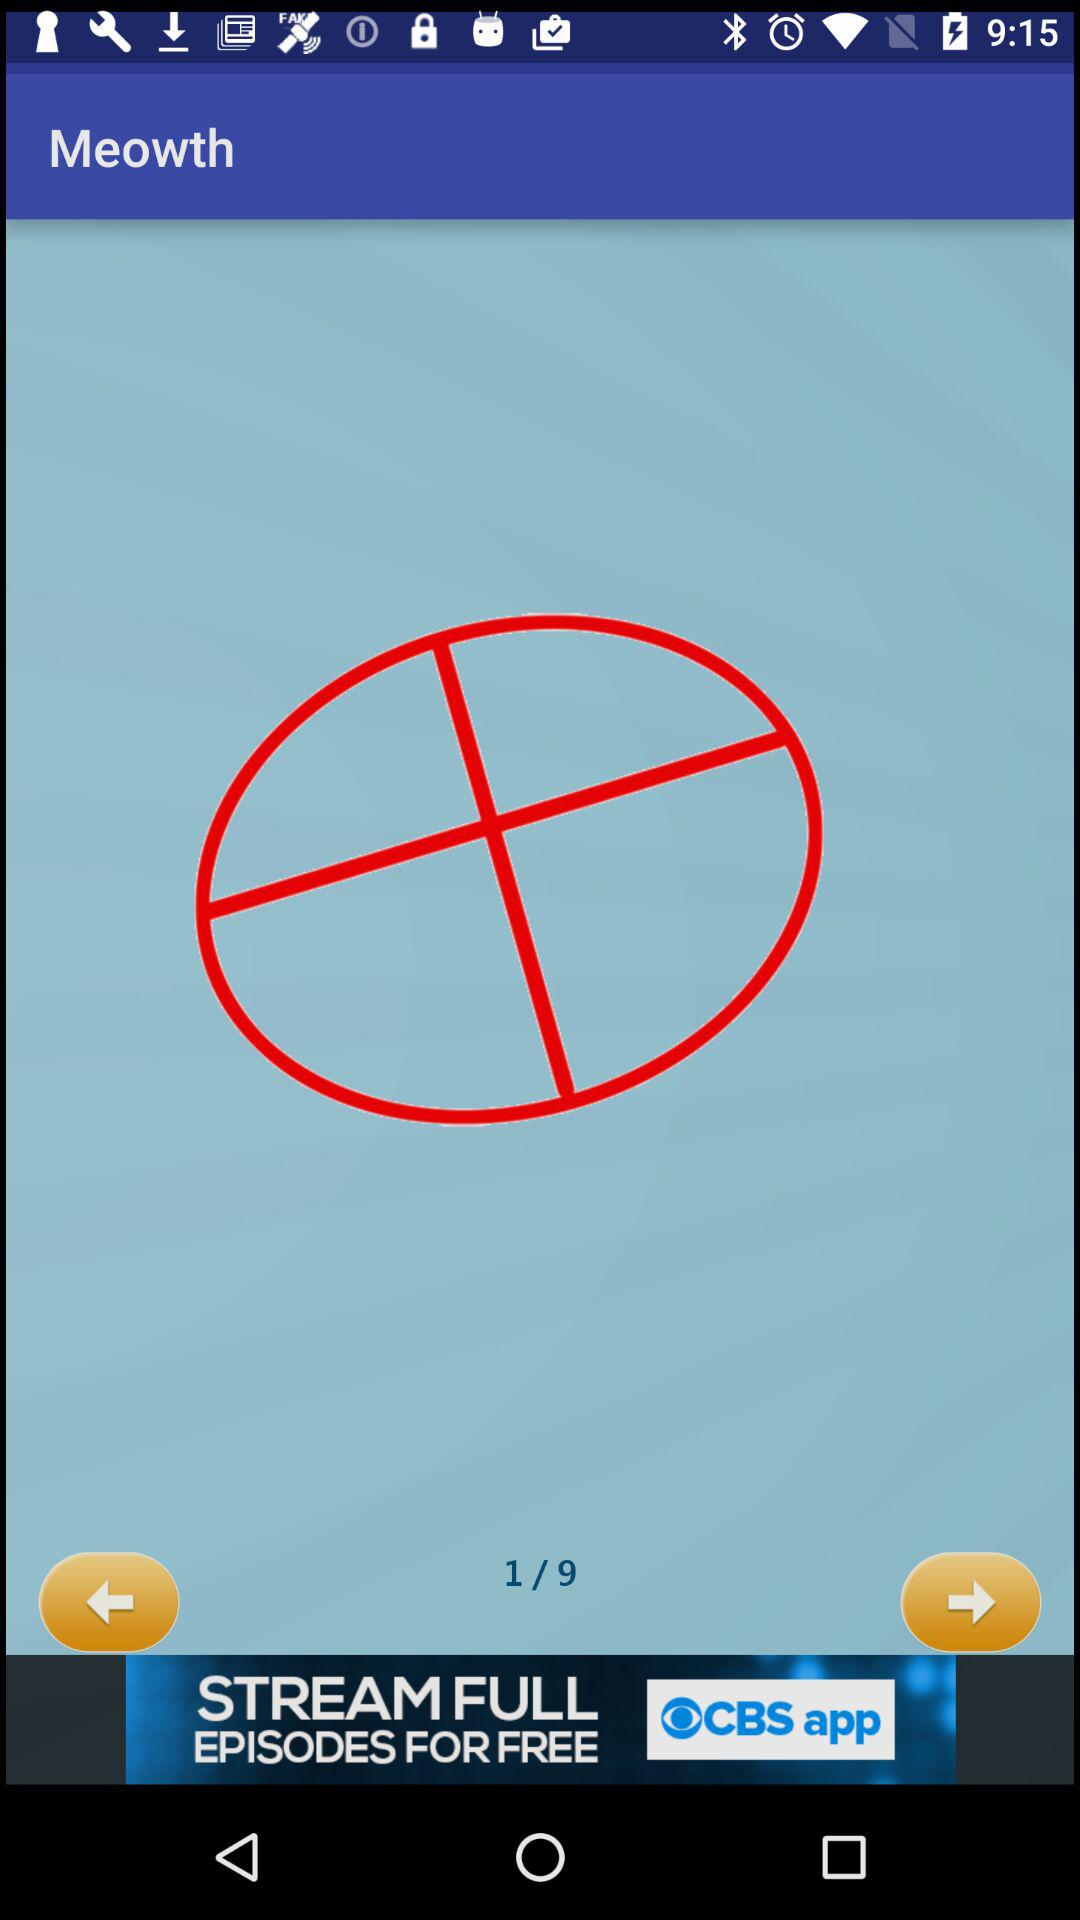Currently, we are on what page number? You are on page number 1. 